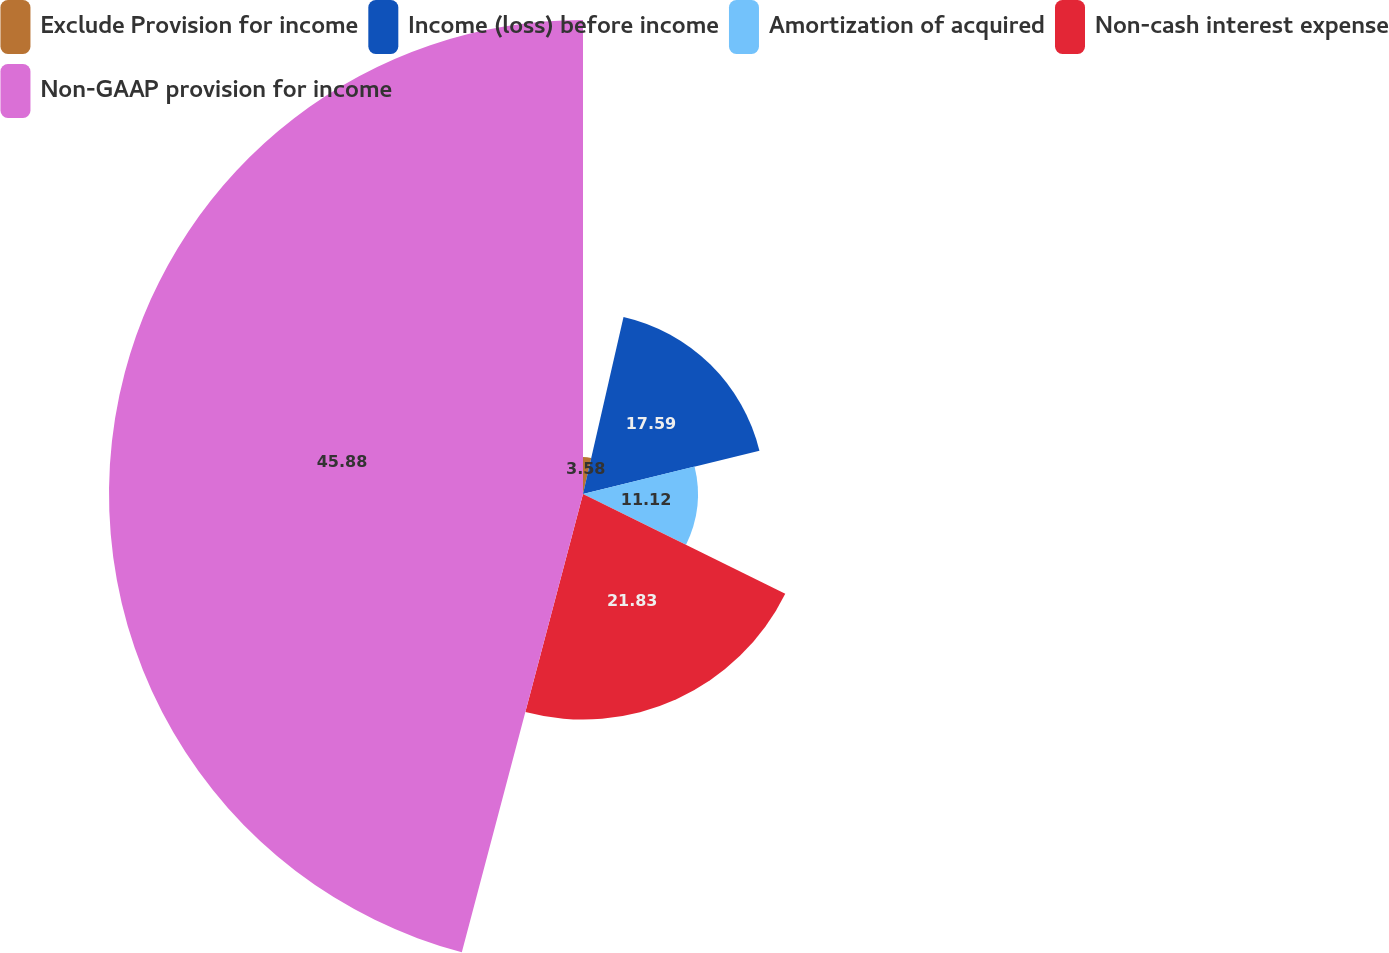Convert chart. <chart><loc_0><loc_0><loc_500><loc_500><pie_chart><fcel>Exclude Provision for income<fcel>Income (loss) before income<fcel>Amortization of acquired<fcel>Non-cash interest expense<fcel>Non-GAAP provision for income<nl><fcel>3.58%<fcel>17.59%<fcel>11.12%<fcel>21.83%<fcel>45.89%<nl></chart> 